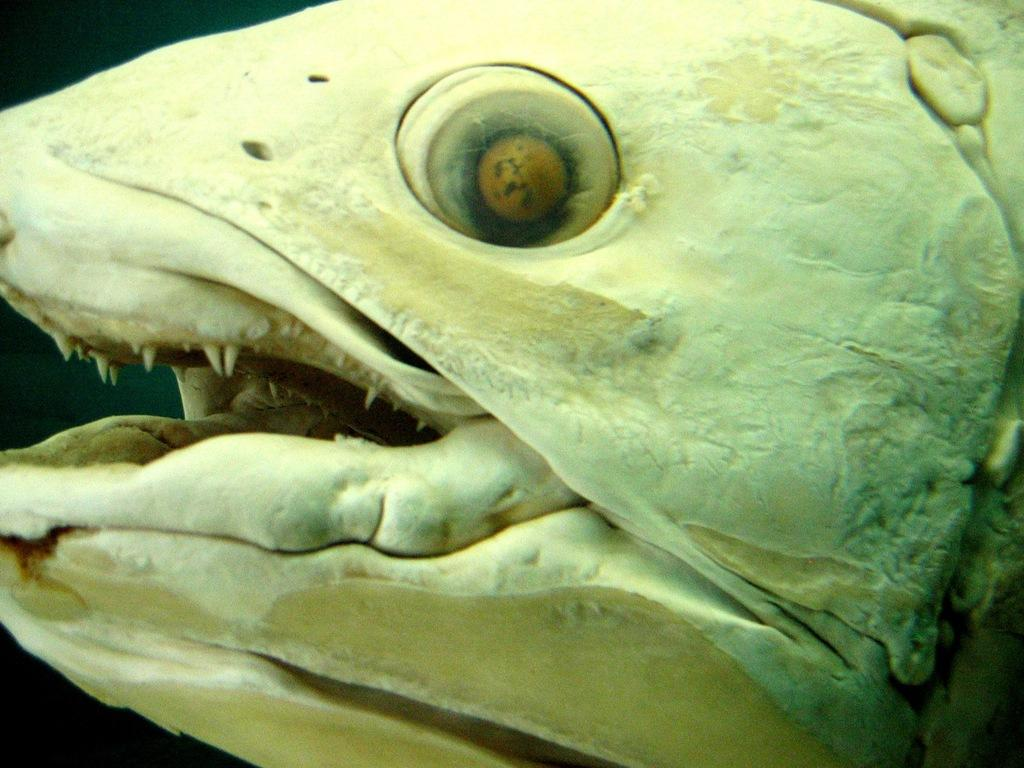What is the main subject of the image? The main subject of the image is a fish head. What can be observed about the background of the image? The background of the image is dark. How many oranges are stacked on top of the fish head in the image? There are no oranges present in the image; the main subject is a fish head. What type of guide is mentioned in the image? There is no guide mentioned in the image; the main subjects are a fish head and a dark background. 